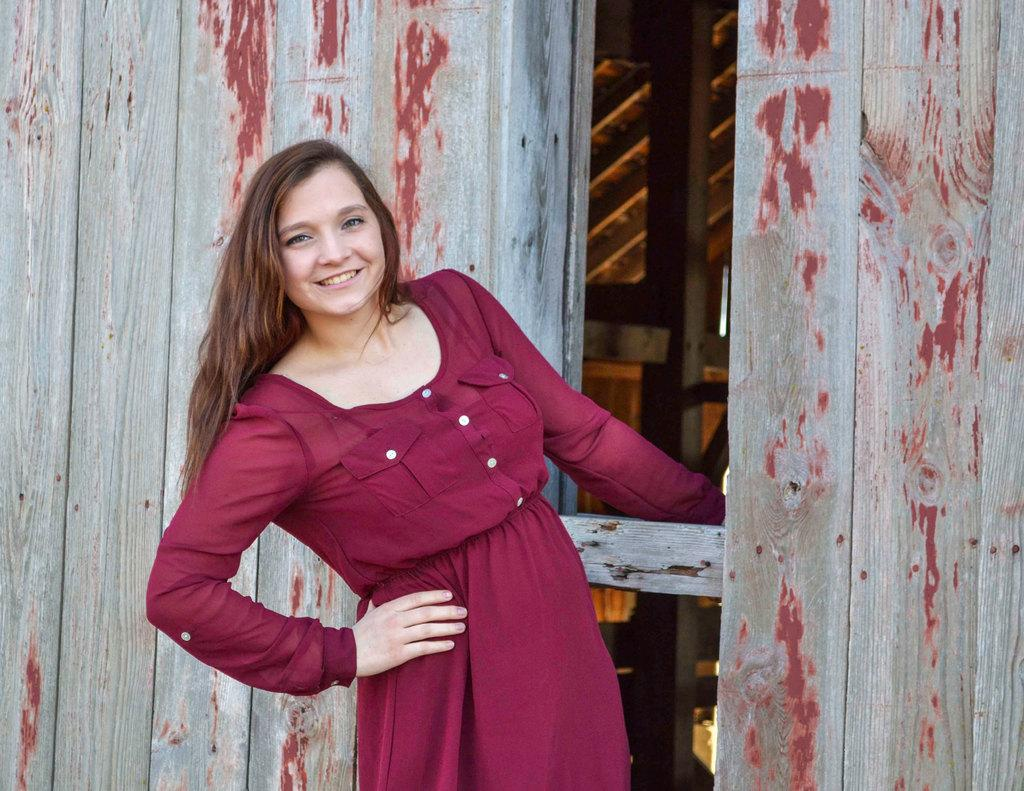Who is the main subject in the image? There is a girl in the image. What is the girl holding in the image? The girl is holding a wooden stick. What is the wooden stick part of? The wooden stick is part of a wooden house. What type of ring is the girl wearing on her finger in the image? There is no ring visible on the girl's finger in the image. What does the girl's brain look like in the image? The girl's brain is not visible in the image, as it is an external view of the girl holding a wooden stick. 